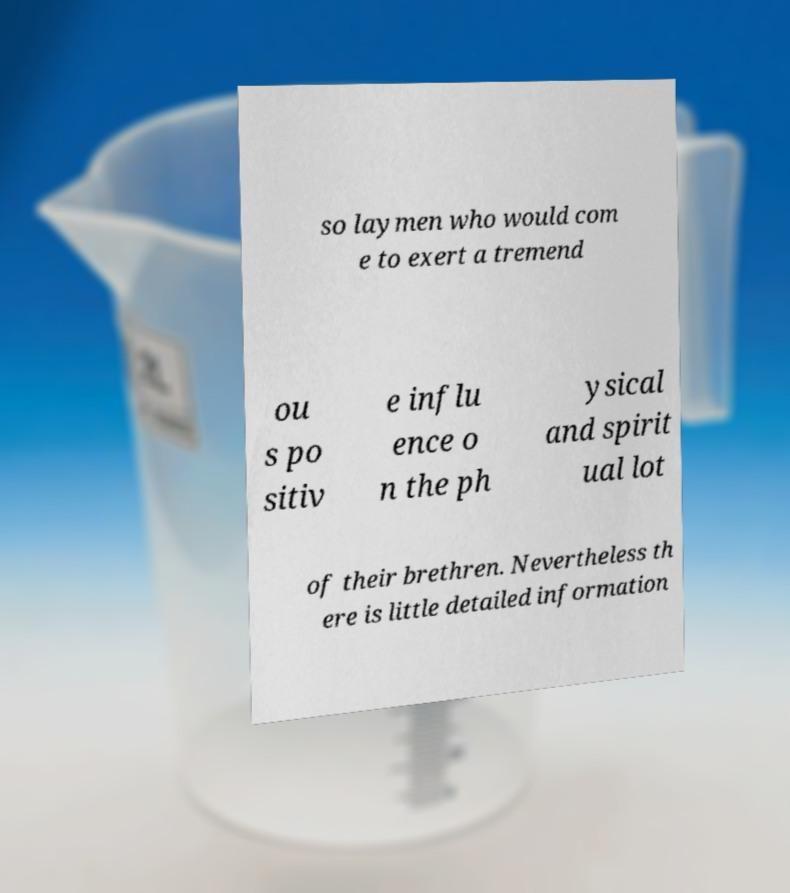I need the written content from this picture converted into text. Can you do that? so laymen who would com e to exert a tremend ou s po sitiv e influ ence o n the ph ysical and spirit ual lot of their brethren. Nevertheless th ere is little detailed information 